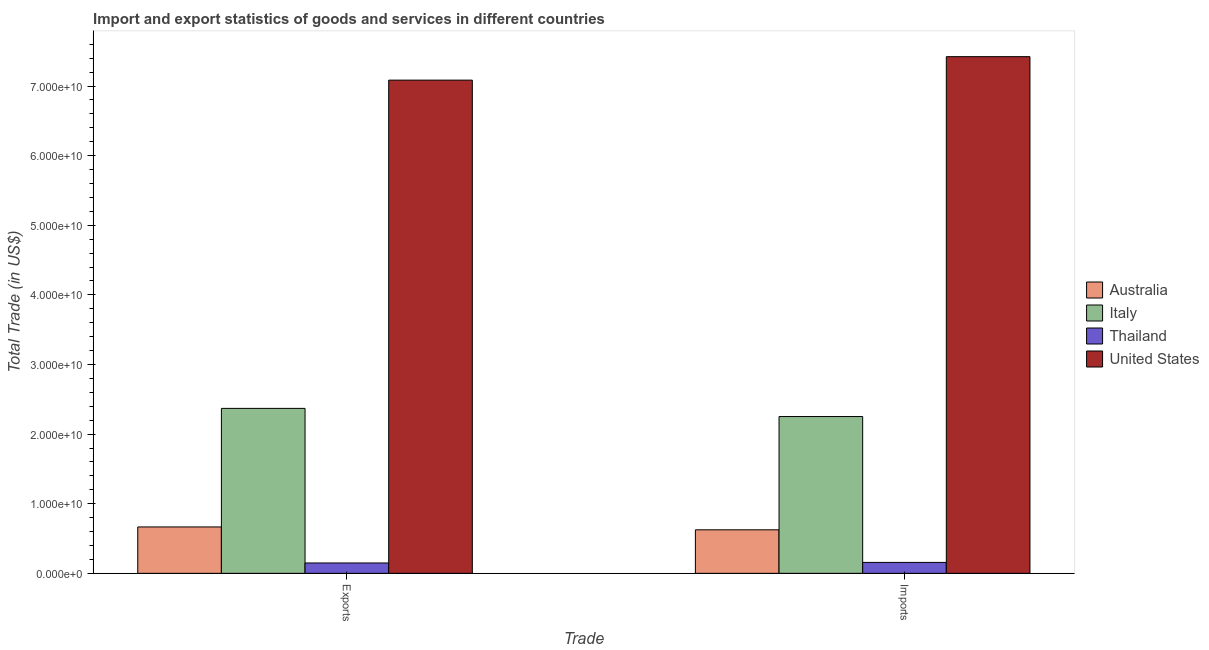What is the label of the 2nd group of bars from the left?
Keep it short and to the point. Imports. What is the imports of goods and services in Italy?
Offer a very short reply. 2.25e+1. Across all countries, what is the maximum export of goods and services?
Your answer should be compact. 7.08e+1. Across all countries, what is the minimum imports of goods and services?
Offer a very short reply. 1.57e+09. In which country was the export of goods and services maximum?
Give a very brief answer. United States. In which country was the imports of goods and services minimum?
Ensure brevity in your answer.  Thailand. What is the total export of goods and services in the graph?
Your answer should be very brief. 1.03e+11. What is the difference between the imports of goods and services in Italy and that in Thailand?
Ensure brevity in your answer.  2.10e+1. What is the difference between the imports of goods and services in Thailand and the export of goods and services in Australia?
Ensure brevity in your answer.  -5.09e+09. What is the average imports of goods and services per country?
Your answer should be compact. 2.61e+1. What is the difference between the export of goods and services and imports of goods and services in United States?
Ensure brevity in your answer.  -3.37e+09. In how many countries, is the export of goods and services greater than 18000000000 US$?
Your answer should be compact. 2. What is the ratio of the export of goods and services in United States to that in Thailand?
Offer a terse response. 47.63. Is the export of goods and services in United States less than that in Thailand?
Offer a very short reply. No. In how many countries, is the export of goods and services greater than the average export of goods and services taken over all countries?
Offer a terse response. 1. What does the 1st bar from the right in Imports represents?
Your response must be concise. United States. Are all the bars in the graph horizontal?
Offer a very short reply. No. How many countries are there in the graph?
Keep it short and to the point. 4. What is the difference between two consecutive major ticks on the Y-axis?
Give a very brief answer. 1.00e+1. How are the legend labels stacked?
Offer a terse response. Vertical. What is the title of the graph?
Ensure brevity in your answer.  Import and export statistics of goods and services in different countries. Does "United States" appear as one of the legend labels in the graph?
Offer a very short reply. Yes. What is the label or title of the X-axis?
Offer a terse response. Trade. What is the label or title of the Y-axis?
Your answer should be very brief. Total Trade (in US$). What is the Total Trade (in US$) in Australia in Exports?
Give a very brief answer. 6.66e+09. What is the Total Trade (in US$) in Italy in Exports?
Keep it short and to the point. 2.37e+1. What is the Total Trade (in US$) in Thailand in Exports?
Give a very brief answer. 1.49e+09. What is the Total Trade (in US$) in United States in Exports?
Offer a terse response. 7.08e+1. What is the Total Trade (in US$) in Australia in Imports?
Keep it short and to the point. 6.25e+09. What is the Total Trade (in US$) in Italy in Imports?
Your response must be concise. 2.25e+1. What is the Total Trade (in US$) in Thailand in Imports?
Provide a succinct answer. 1.57e+09. What is the Total Trade (in US$) of United States in Imports?
Your answer should be very brief. 7.42e+1. Across all Trade, what is the maximum Total Trade (in US$) of Australia?
Give a very brief answer. 6.66e+09. Across all Trade, what is the maximum Total Trade (in US$) of Italy?
Your answer should be very brief. 2.37e+1. Across all Trade, what is the maximum Total Trade (in US$) of Thailand?
Your answer should be very brief. 1.57e+09. Across all Trade, what is the maximum Total Trade (in US$) of United States?
Make the answer very short. 7.42e+1. Across all Trade, what is the minimum Total Trade (in US$) of Australia?
Provide a short and direct response. 6.25e+09. Across all Trade, what is the minimum Total Trade (in US$) of Italy?
Make the answer very short. 2.25e+1. Across all Trade, what is the minimum Total Trade (in US$) in Thailand?
Your answer should be compact. 1.49e+09. Across all Trade, what is the minimum Total Trade (in US$) in United States?
Provide a succinct answer. 7.08e+1. What is the total Total Trade (in US$) of Australia in the graph?
Your response must be concise. 1.29e+1. What is the total Total Trade (in US$) in Italy in the graph?
Your answer should be compact. 4.62e+1. What is the total Total Trade (in US$) of Thailand in the graph?
Make the answer very short. 3.06e+09. What is the total Total Trade (in US$) in United States in the graph?
Make the answer very short. 1.45e+11. What is the difference between the Total Trade (in US$) in Australia in Exports and that in Imports?
Your response must be concise. 4.12e+08. What is the difference between the Total Trade (in US$) of Italy in Exports and that in Imports?
Your answer should be compact. 1.17e+09. What is the difference between the Total Trade (in US$) in Thailand in Exports and that in Imports?
Your answer should be very brief. -8.13e+07. What is the difference between the Total Trade (in US$) in United States in Exports and that in Imports?
Provide a succinct answer. -3.37e+09. What is the difference between the Total Trade (in US$) of Australia in Exports and the Total Trade (in US$) of Italy in Imports?
Your answer should be compact. -1.59e+1. What is the difference between the Total Trade (in US$) in Australia in Exports and the Total Trade (in US$) in Thailand in Imports?
Offer a very short reply. 5.09e+09. What is the difference between the Total Trade (in US$) of Australia in Exports and the Total Trade (in US$) of United States in Imports?
Offer a very short reply. -6.76e+1. What is the difference between the Total Trade (in US$) in Italy in Exports and the Total Trade (in US$) in Thailand in Imports?
Your response must be concise. 2.21e+1. What is the difference between the Total Trade (in US$) in Italy in Exports and the Total Trade (in US$) in United States in Imports?
Provide a succinct answer. -5.05e+1. What is the difference between the Total Trade (in US$) of Thailand in Exports and the Total Trade (in US$) of United States in Imports?
Your answer should be compact. -7.27e+1. What is the average Total Trade (in US$) of Australia per Trade?
Your answer should be very brief. 6.46e+09. What is the average Total Trade (in US$) in Italy per Trade?
Make the answer very short. 2.31e+1. What is the average Total Trade (in US$) in Thailand per Trade?
Keep it short and to the point. 1.53e+09. What is the average Total Trade (in US$) of United States per Trade?
Your response must be concise. 7.25e+1. What is the difference between the Total Trade (in US$) in Australia and Total Trade (in US$) in Italy in Exports?
Give a very brief answer. -1.70e+1. What is the difference between the Total Trade (in US$) of Australia and Total Trade (in US$) of Thailand in Exports?
Your answer should be compact. 5.18e+09. What is the difference between the Total Trade (in US$) in Australia and Total Trade (in US$) in United States in Exports?
Your response must be concise. -6.42e+1. What is the difference between the Total Trade (in US$) in Italy and Total Trade (in US$) in Thailand in Exports?
Give a very brief answer. 2.22e+1. What is the difference between the Total Trade (in US$) of Italy and Total Trade (in US$) of United States in Exports?
Provide a short and direct response. -4.72e+1. What is the difference between the Total Trade (in US$) of Thailand and Total Trade (in US$) of United States in Exports?
Your answer should be very brief. -6.94e+1. What is the difference between the Total Trade (in US$) in Australia and Total Trade (in US$) in Italy in Imports?
Provide a short and direct response. -1.63e+1. What is the difference between the Total Trade (in US$) in Australia and Total Trade (in US$) in Thailand in Imports?
Offer a terse response. 4.68e+09. What is the difference between the Total Trade (in US$) in Australia and Total Trade (in US$) in United States in Imports?
Keep it short and to the point. -6.80e+1. What is the difference between the Total Trade (in US$) in Italy and Total Trade (in US$) in Thailand in Imports?
Provide a short and direct response. 2.10e+1. What is the difference between the Total Trade (in US$) in Italy and Total Trade (in US$) in United States in Imports?
Make the answer very short. -5.17e+1. What is the difference between the Total Trade (in US$) of Thailand and Total Trade (in US$) of United States in Imports?
Provide a short and direct response. -7.26e+1. What is the ratio of the Total Trade (in US$) in Australia in Exports to that in Imports?
Your answer should be compact. 1.07. What is the ratio of the Total Trade (in US$) in Italy in Exports to that in Imports?
Give a very brief answer. 1.05. What is the ratio of the Total Trade (in US$) in Thailand in Exports to that in Imports?
Make the answer very short. 0.95. What is the ratio of the Total Trade (in US$) of United States in Exports to that in Imports?
Your answer should be very brief. 0.95. What is the difference between the highest and the second highest Total Trade (in US$) of Australia?
Offer a very short reply. 4.12e+08. What is the difference between the highest and the second highest Total Trade (in US$) in Italy?
Ensure brevity in your answer.  1.17e+09. What is the difference between the highest and the second highest Total Trade (in US$) of Thailand?
Provide a short and direct response. 8.13e+07. What is the difference between the highest and the second highest Total Trade (in US$) in United States?
Provide a short and direct response. 3.37e+09. What is the difference between the highest and the lowest Total Trade (in US$) in Australia?
Your response must be concise. 4.12e+08. What is the difference between the highest and the lowest Total Trade (in US$) in Italy?
Your answer should be very brief. 1.17e+09. What is the difference between the highest and the lowest Total Trade (in US$) in Thailand?
Offer a very short reply. 8.13e+07. What is the difference between the highest and the lowest Total Trade (in US$) in United States?
Your response must be concise. 3.37e+09. 